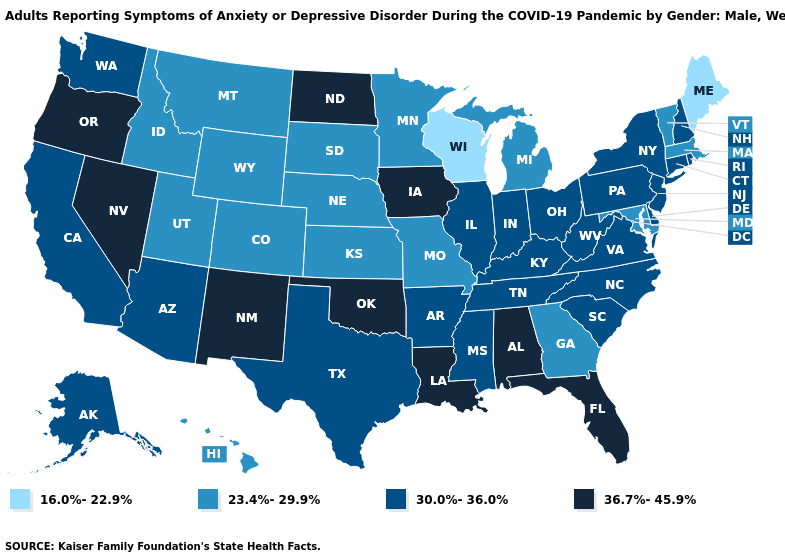Among the states that border Virginia , does West Virginia have the lowest value?
Quick response, please. No. What is the value of West Virginia?
Be succinct. 30.0%-36.0%. What is the value of Wisconsin?
Answer briefly. 16.0%-22.9%. Name the states that have a value in the range 36.7%-45.9%?
Be succinct. Alabama, Florida, Iowa, Louisiana, Nevada, New Mexico, North Dakota, Oklahoma, Oregon. What is the value of Oregon?
Be succinct. 36.7%-45.9%. Name the states that have a value in the range 16.0%-22.9%?
Short answer required. Maine, Wisconsin. Does the map have missing data?
Concise answer only. No. Which states have the lowest value in the West?
Give a very brief answer. Colorado, Hawaii, Idaho, Montana, Utah, Wyoming. What is the highest value in the South ?
Short answer required. 36.7%-45.9%. Which states have the lowest value in the USA?
Concise answer only. Maine, Wisconsin. Does North Carolina have the same value as Texas?
Be succinct. Yes. What is the highest value in the MidWest ?
Give a very brief answer. 36.7%-45.9%. What is the value of Delaware?
Short answer required. 30.0%-36.0%. Name the states that have a value in the range 36.7%-45.9%?
Keep it brief. Alabama, Florida, Iowa, Louisiana, Nevada, New Mexico, North Dakota, Oklahoma, Oregon. 